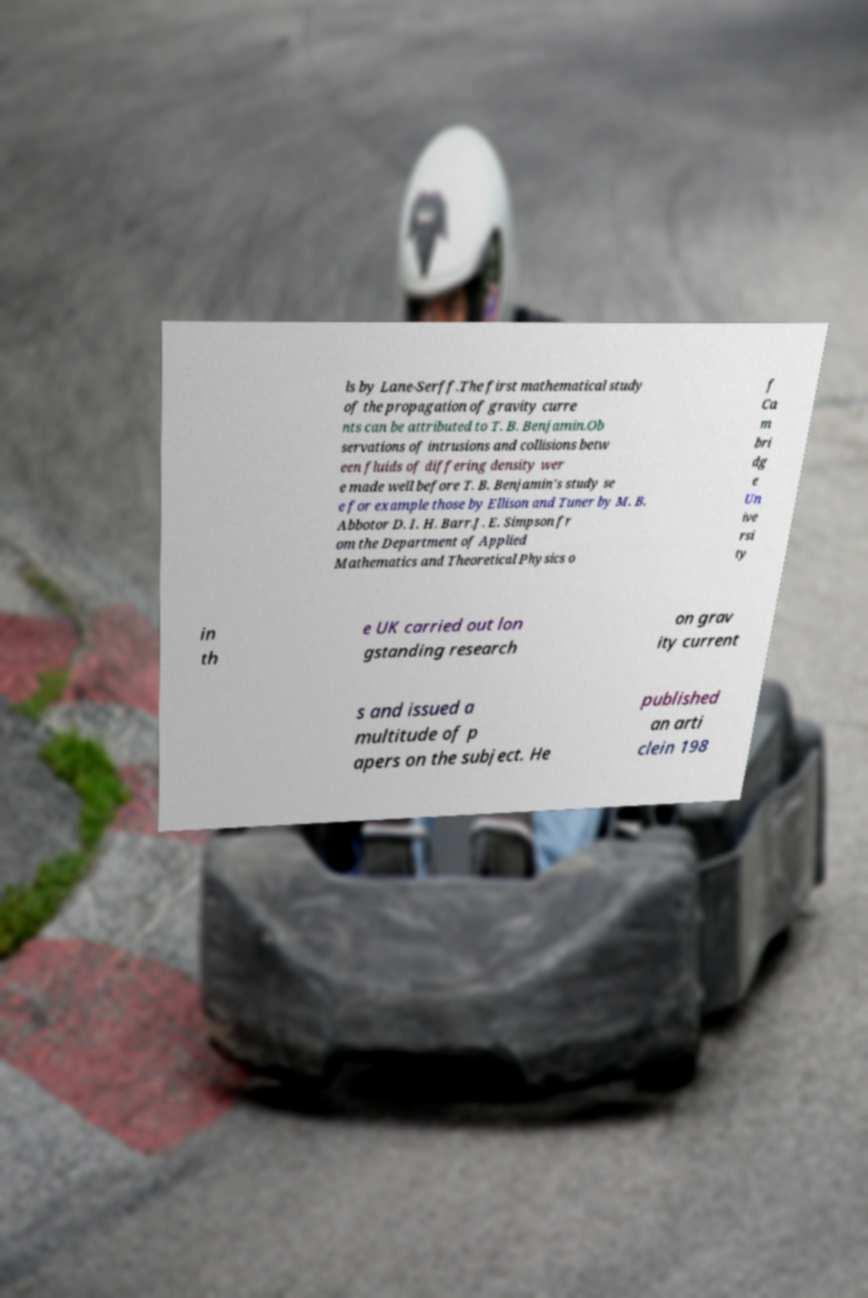Could you extract and type out the text from this image? ls by Lane-Serff.The first mathematical study of the propagation of gravity curre nts can be attributed to T. B. Benjamin.Ob servations of intrusions and collisions betw een fluids of differing density wer e made well before T. B. Benjamin's study se e for example those by Ellison and Tuner by M. B. Abbotor D. I. H. Barr.J. E. Simpson fr om the Department of Applied Mathematics and Theoretical Physics o f Ca m bri dg e Un ive rsi ty in th e UK carried out lon gstanding research on grav ity current s and issued a multitude of p apers on the subject. He published an arti clein 198 